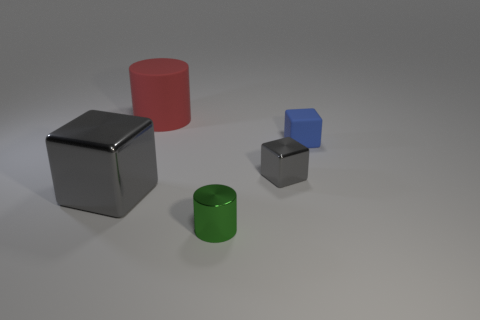Add 4 big metal cubes. How many objects exist? 9 Subtract all cylinders. How many objects are left? 3 Subtract all tiny green cylinders. Subtract all tiny gray things. How many objects are left? 3 Add 1 small gray objects. How many small gray objects are left? 2 Add 5 small cubes. How many small cubes exist? 7 Subtract 0 purple spheres. How many objects are left? 5 